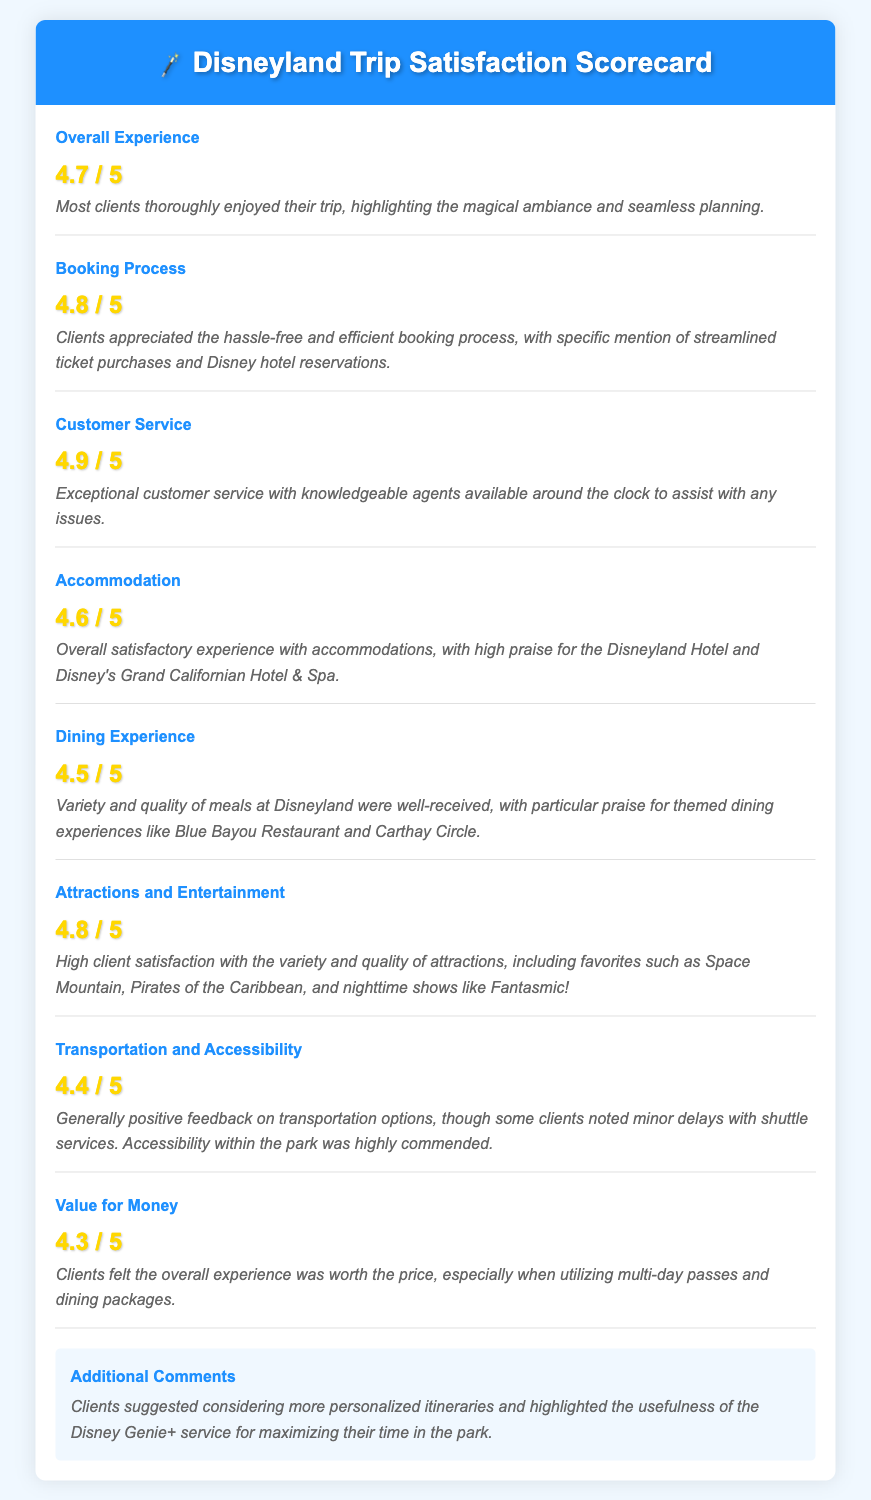What is the overall satisfaction score? The overall satisfaction score is found in the "Overall Experience" section of the document, which is rated at 4.7 out of 5.
Answer: 4.7 / 5 What is the score for Customer Service? The score for Customer Service can be found in the corresponding aspect of the scorecard, which is rated at 4.9 out of 5.
Answer: 4.9 / 5 Which hotel received high praise in the Accommodation category? The document specifies that the Disneyland Hotel and Disney's Grand Californian Hotel & Spa received high praise in the Accommodation section.
Answer: Disneyland Hotel and Disney's Grand Californian Hotel & Spa What is the score for Transportation and Accessibility? The score for Transportation and Accessibility is located under that specific aspect, which is rated at 4.4 out of 5.
Answer: 4.4 / 5 What did clients suggest regarding itineraries? The additional comments section indicates clients suggested considering more personalized itineraries.
Answer: More personalized itineraries What aspect received the highest score? To find the aspect with the highest score, we compare all scores; Customer Service has the highest score at 4.9 out of 5.
Answer: Customer Service What feedback was given about the Dining Experience? The comments in the Dining Experience section highlight praise for the variety and quality of meals at Disneyland.
Answer: Variety and quality of meals What could clients use to maximize their time in the park? The additional comments mention the usefulness of the Disney Genie+ service for maximizing their time.
Answer: Disney Genie+ service 